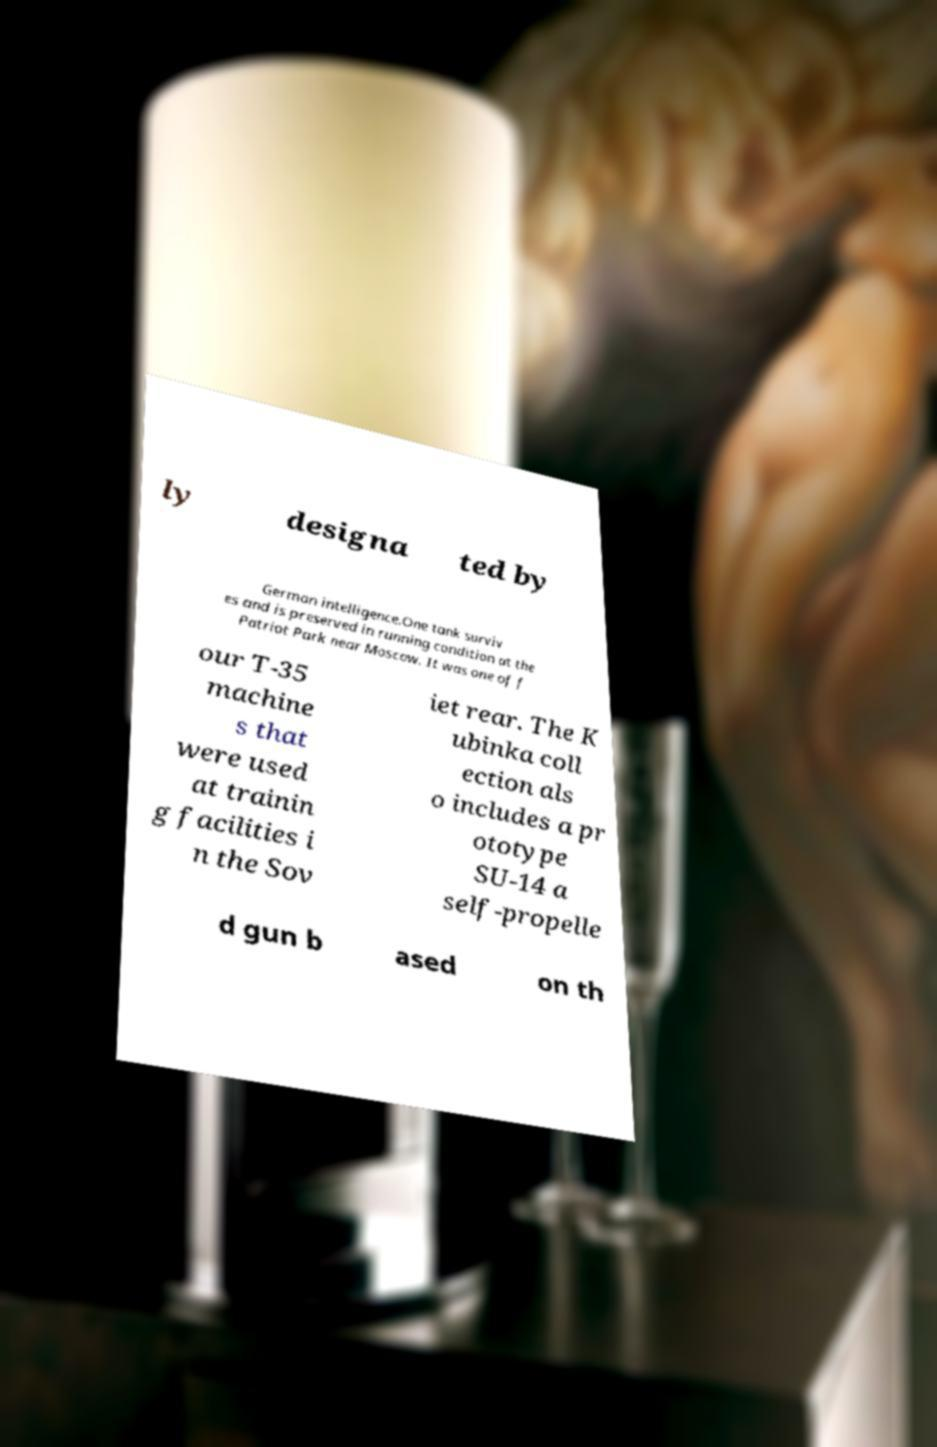Could you assist in decoding the text presented in this image and type it out clearly? ly designa ted by German intelligence.One tank surviv es and is preserved in running condition at the Patriot Park near Moscow. It was one of f our T-35 machine s that were used at trainin g facilities i n the Sov iet rear. The K ubinka coll ection als o includes a pr ototype SU-14 a self-propelle d gun b ased on th 